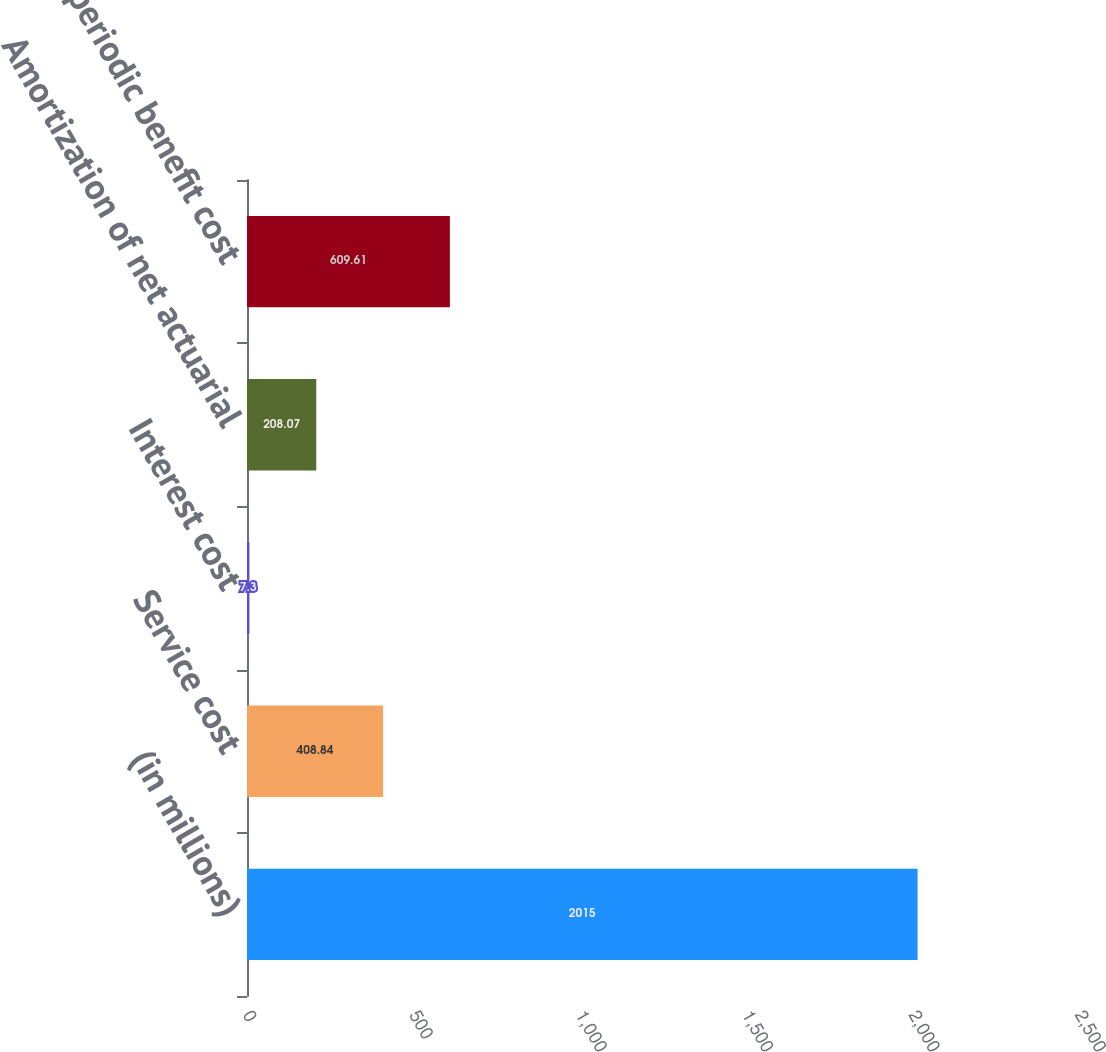Convert chart. <chart><loc_0><loc_0><loc_500><loc_500><bar_chart><fcel>(in millions)<fcel>Service cost<fcel>Interest cost<fcel>Amortization of net actuarial<fcel>Net periodic benefit cost<nl><fcel>2015<fcel>408.84<fcel>7.3<fcel>208.07<fcel>609.61<nl></chart> 